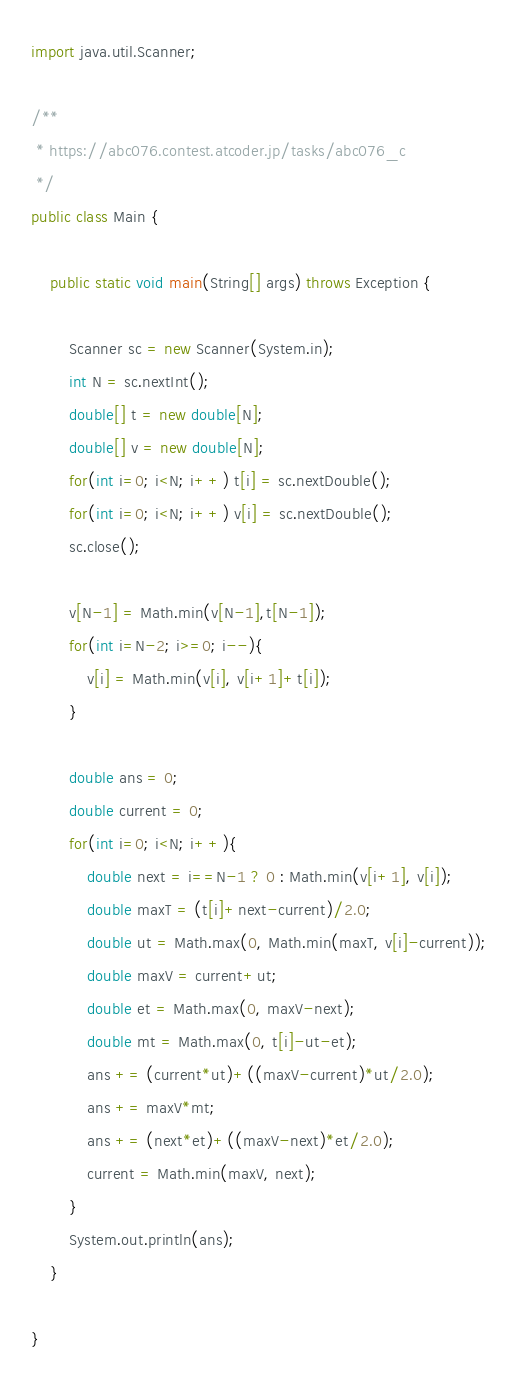Convert code to text. <code><loc_0><loc_0><loc_500><loc_500><_Java_>import java.util.Scanner;

/**
 * https://abc076.contest.atcoder.jp/tasks/abc076_c
 */
public class Main {

	public static void main(String[] args) throws Exception {
		
		Scanner sc = new Scanner(System.in);
		int N = sc.nextInt();
		double[] t = new double[N];
		double[] v = new double[N];
		for(int i=0; i<N; i++) t[i] = sc.nextDouble();
		for(int i=0; i<N; i++) v[i] = sc.nextDouble();
		sc.close();
	
		v[N-1] = Math.min(v[N-1],t[N-1]);
		for(int i=N-2; i>=0; i--){
			v[i] = Math.min(v[i], v[i+1]+t[i]);
		}
		
		double ans = 0;
		double current = 0;
		for(int i=0; i<N; i++){
			double next = i==N-1 ? 0 : Math.min(v[i+1], v[i]);
			double maxT = (t[i]+next-current)/2.0;
			double ut = Math.max(0, Math.min(maxT, v[i]-current));
			double maxV = current+ut;
			double et = Math.max(0, maxV-next);
			double mt = Math.max(0, t[i]-ut-et);
			ans += (current*ut)+((maxV-current)*ut/2.0);
			ans += maxV*mt;
			ans += (next*et)+((maxV-next)*et/2.0);
			current = Math.min(maxV, next);
		}
		System.out.println(ans);
	}

}</code> 